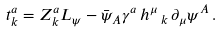<formula> <loc_0><loc_0><loc_500><loc_500>t ^ { a } _ { k } = Z ^ { a } _ { k } L _ { \psi } - \bar { \psi } _ { A } \gamma ^ { a } \, h ^ { \mu } \, _ { k } \, \partial _ { \mu } \psi ^ { A } \, .</formula> 